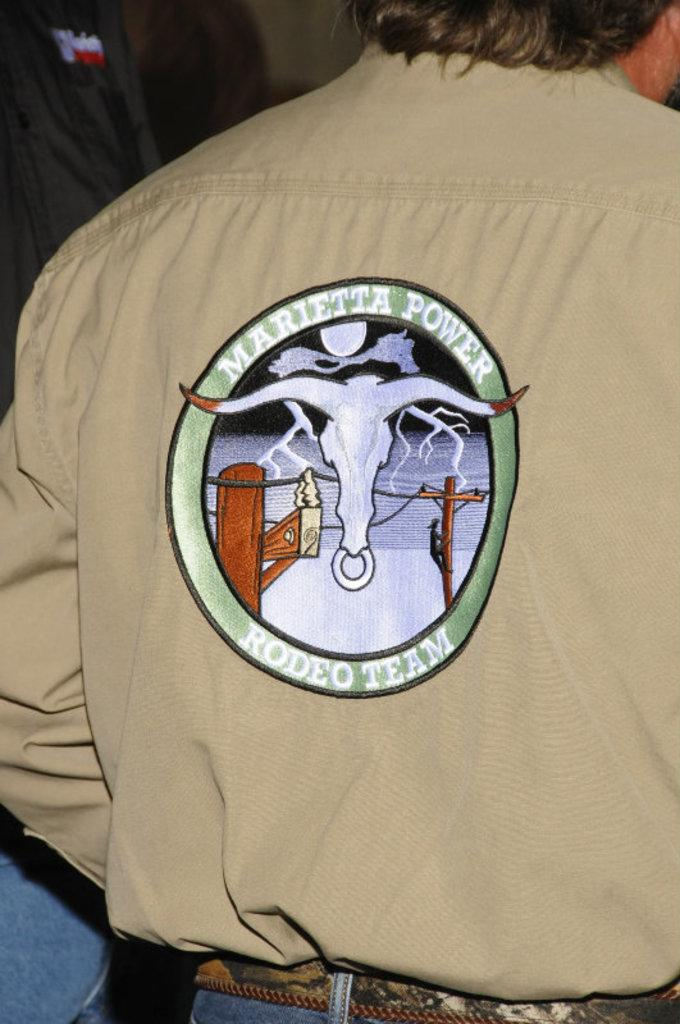<image>
Write a terse but informative summary of the picture. Man wearing a shirt with a logo which says Mariettea Power Rodeo Team. 